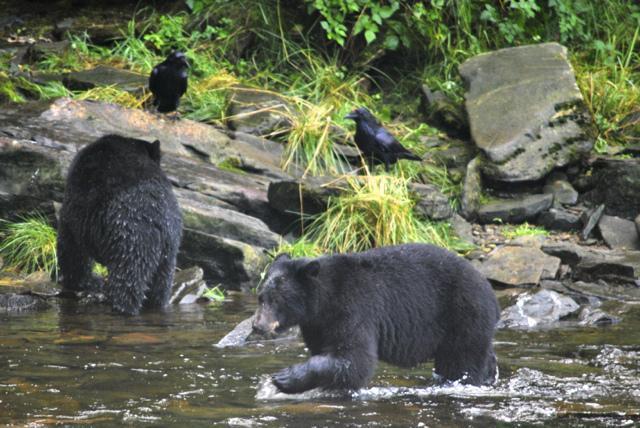How many bears are there?
Give a very brief answer. 2. How many bears are visible?
Give a very brief answer. 2. How many cars have headlights on?
Give a very brief answer. 0. 